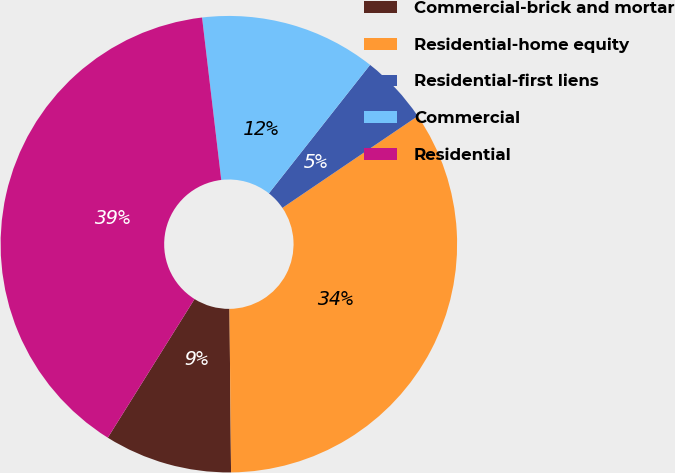<chart> <loc_0><loc_0><loc_500><loc_500><pie_chart><fcel>Commercial-brick and mortar<fcel>Residential-home equity<fcel>Residential-first liens<fcel>Commercial<fcel>Residential<nl><fcel>9.05%<fcel>34.33%<fcel>4.9%<fcel>12.49%<fcel>39.23%<nl></chart> 